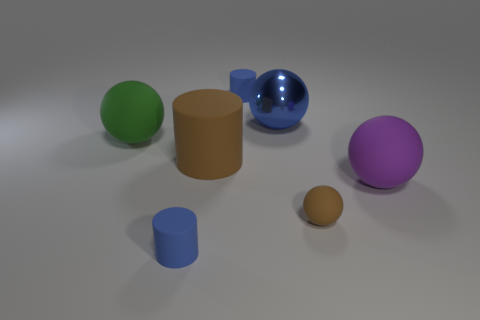Add 2 metallic objects. How many objects exist? 9 Subtract all spheres. How many objects are left? 3 Subtract 1 green spheres. How many objects are left? 6 Subtract all large cyan rubber things. Subtract all big brown cylinders. How many objects are left? 6 Add 5 big spheres. How many big spheres are left? 8 Add 7 big cylinders. How many big cylinders exist? 8 